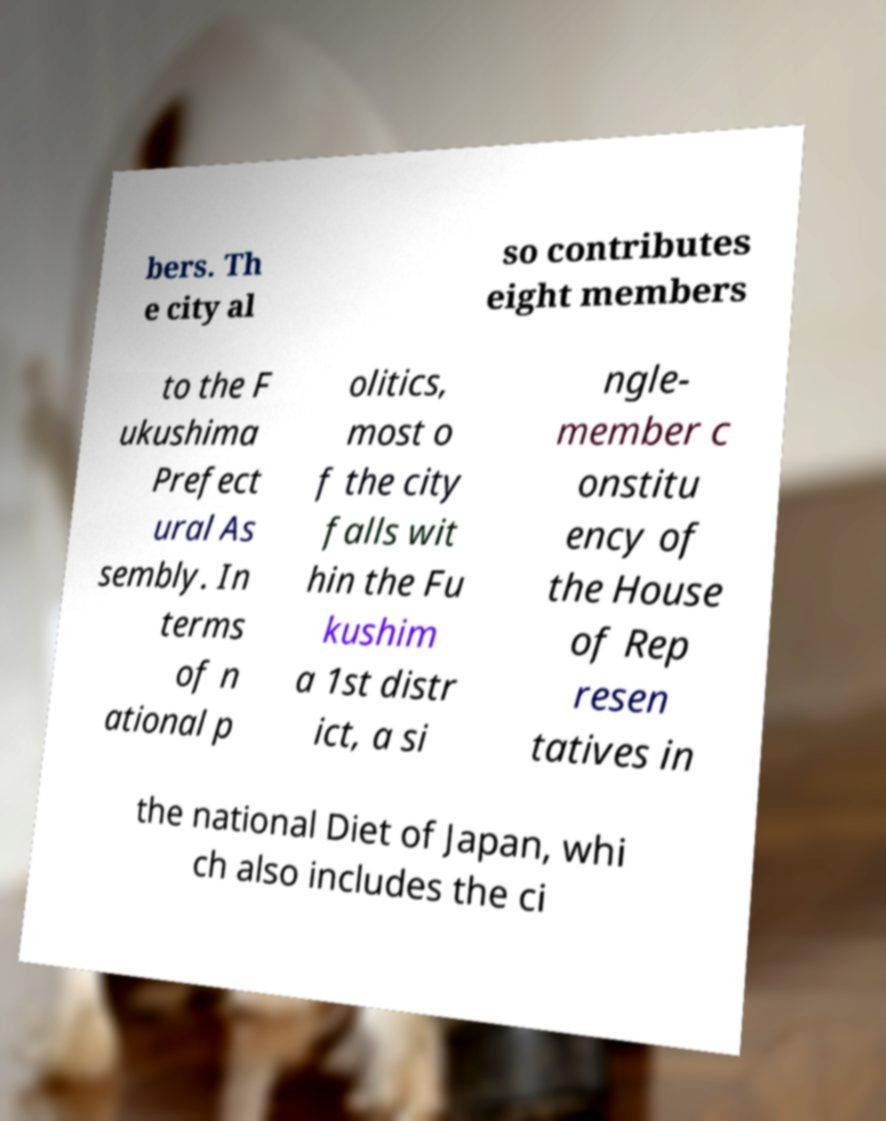Can you read and provide the text displayed in the image?This photo seems to have some interesting text. Can you extract and type it out for me? bers. Th e city al so contributes eight members to the F ukushima Prefect ural As sembly. In terms of n ational p olitics, most o f the city falls wit hin the Fu kushim a 1st distr ict, a si ngle- member c onstitu ency of the House of Rep resen tatives in the national Diet of Japan, whi ch also includes the ci 